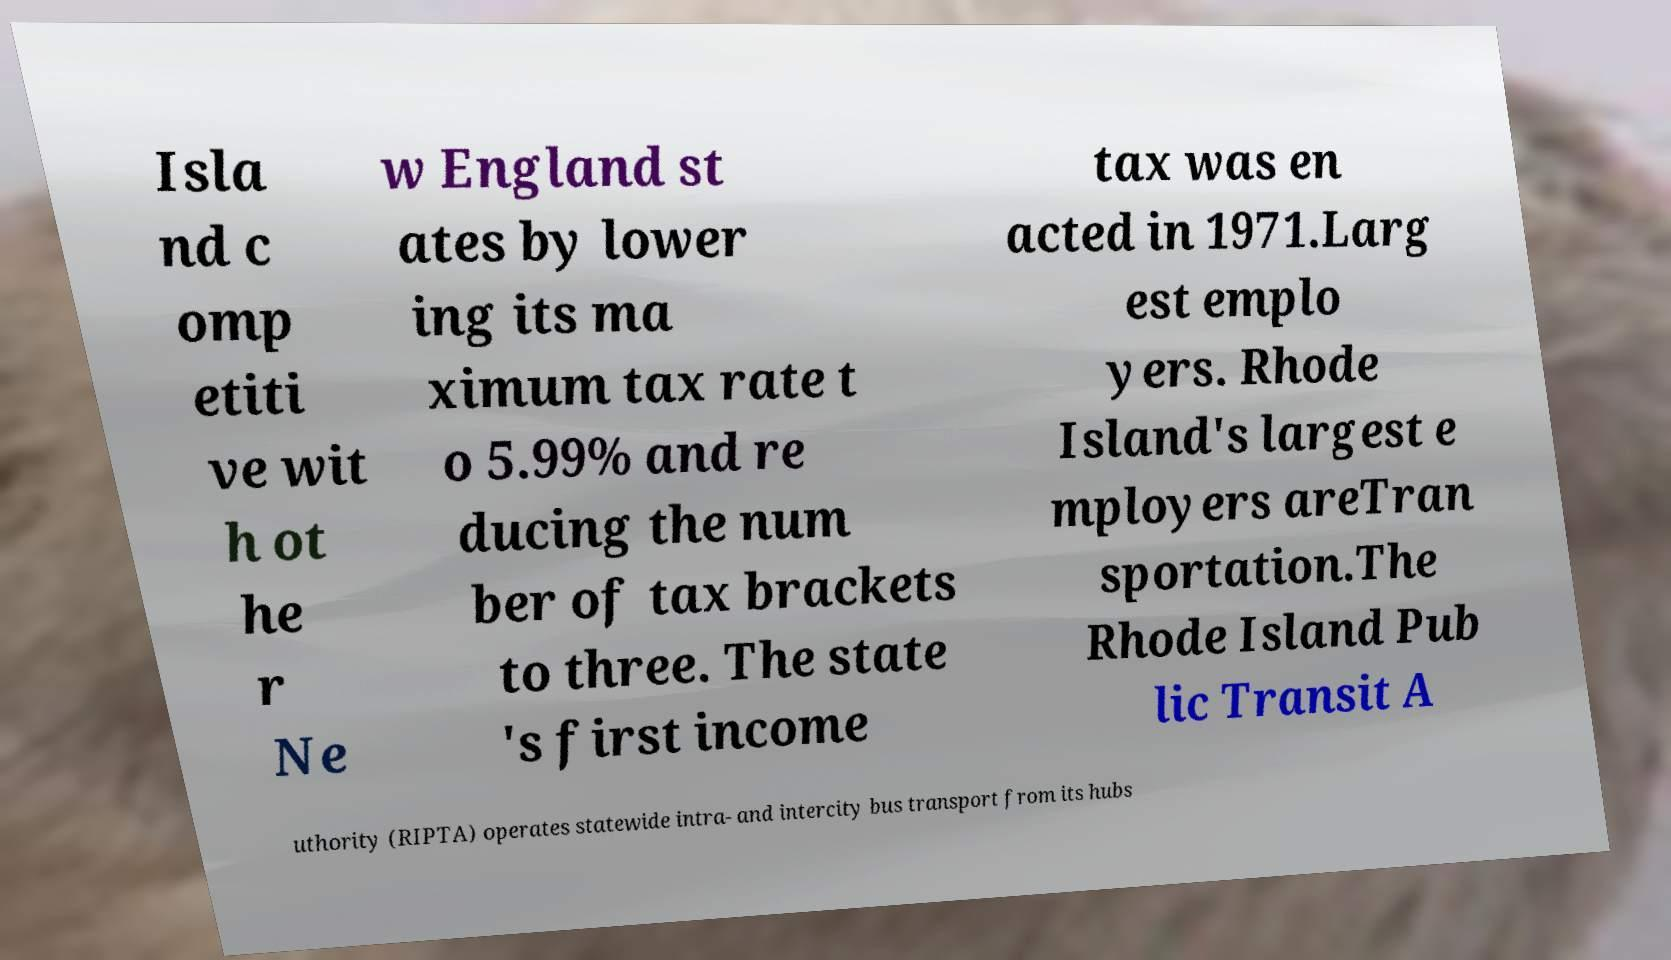Could you extract and type out the text from this image? Isla nd c omp etiti ve wit h ot he r Ne w England st ates by lower ing its ma ximum tax rate t o 5.99% and re ducing the num ber of tax brackets to three. The state 's first income tax was en acted in 1971.Larg est emplo yers. Rhode Island's largest e mployers areTran sportation.The Rhode Island Pub lic Transit A uthority (RIPTA) operates statewide intra- and intercity bus transport from its hubs 